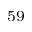Convert formula to latex. <formula><loc_0><loc_0><loc_500><loc_500>^ { 5 9 }</formula> 